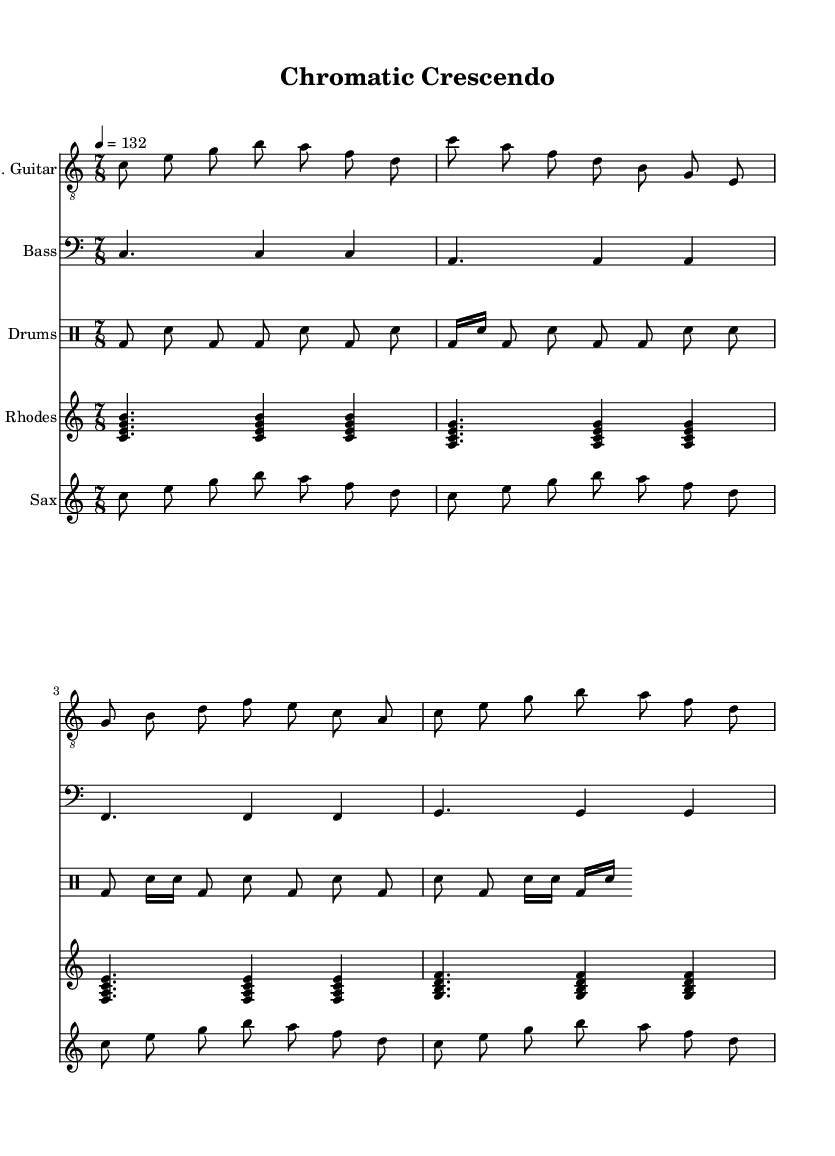What is the key signature of this music? The key signature displayed in the music sheet is C major, which indicates no sharps or flats are present.
Answer: C major What is the time signature of this music? The time signature visible in the music sheet is 7/8, which means there are seven eighth-note beats in each measure.
Answer: 7/8 What is the tempo marking of this piece? The tempo marking of the piece indicates a speed of 132 beats per minute, specified as "4 = 132", which refers to the quarter note.
Answer: 132 How many measures are in the electric guitar part? There are four measures in the electric guitar part, visible by counting the series of vertical bar lines separating the measures.
Answer: 4 Which instruments are present in this composition? The instruments in the composition include electric guitar, bass guitar, drums, Rhodes piano, and saxophone. This is determined by the labeled staves in the score.
Answer: Electric guitar, bass guitar, drums, Rhodes piano, saxophone What rhythmic pattern is used in the drum kit? The rhythmic pattern in the drum kit includes both eighth and sixteenth notes, providing a complex groove typical of jazz-rock fusion, thus demonstrating vibrant and varied rhythmic shifts.
Answer: Eighth and sixteenth notes How does the saxophone melody relate to color theory? The saxophone melody features repeated phrases which shift in pitch color and rhythmic variance, aligning with color theory's exploration of vibrancy and tonal shifts, tying emotions often evoked by various colors into musical expression.
Answer: Varied pitch and rhythm 